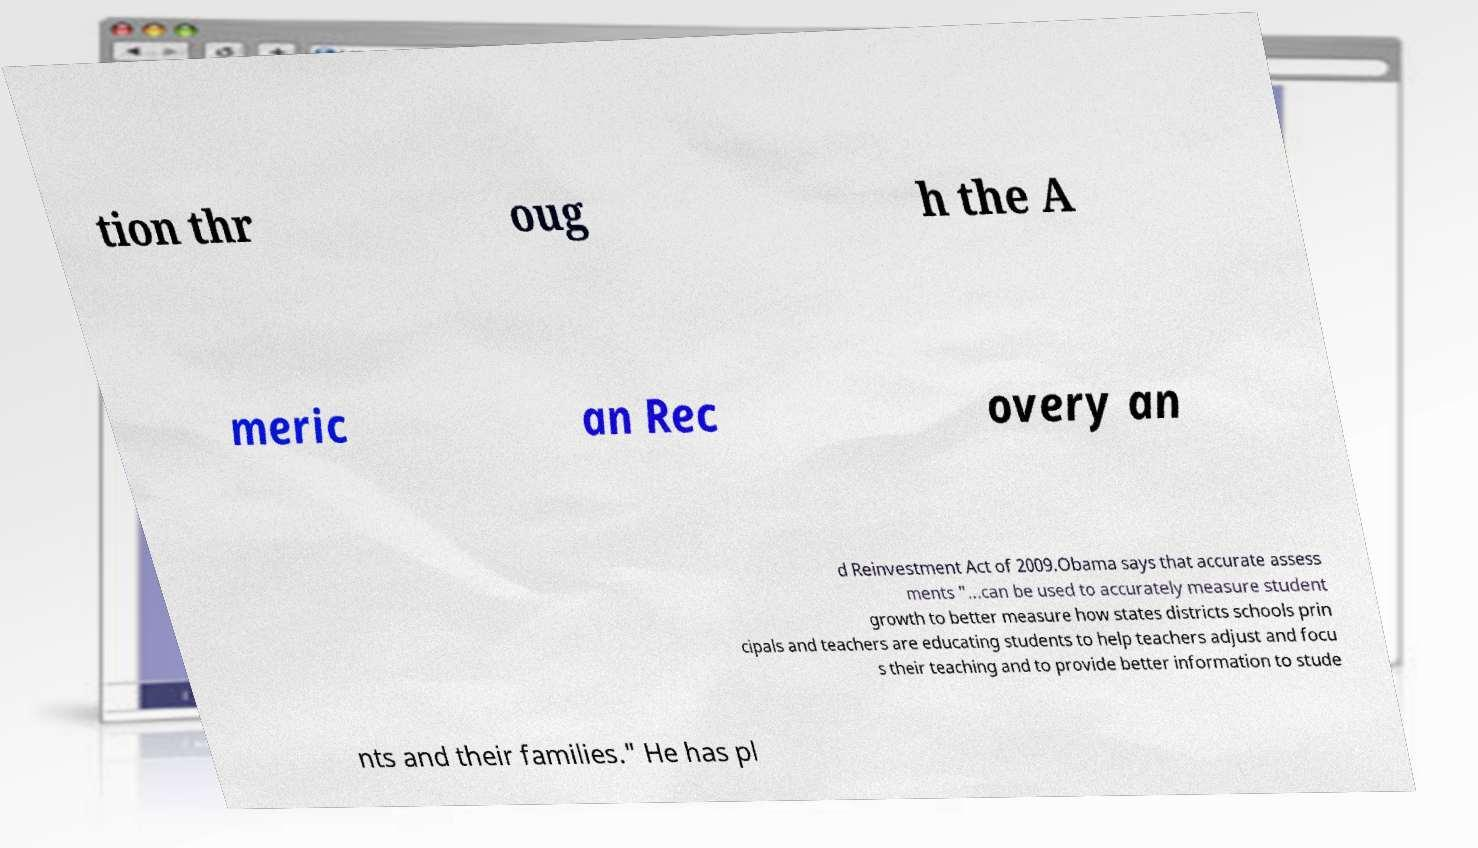Could you extract and type out the text from this image? tion thr oug h the A meric an Rec overy an d Reinvestment Act of 2009.Obama says that accurate assess ments "...can be used to accurately measure student growth to better measure how states districts schools prin cipals and teachers are educating students to help teachers adjust and focu s their teaching and to provide better information to stude nts and their families." He has pl 